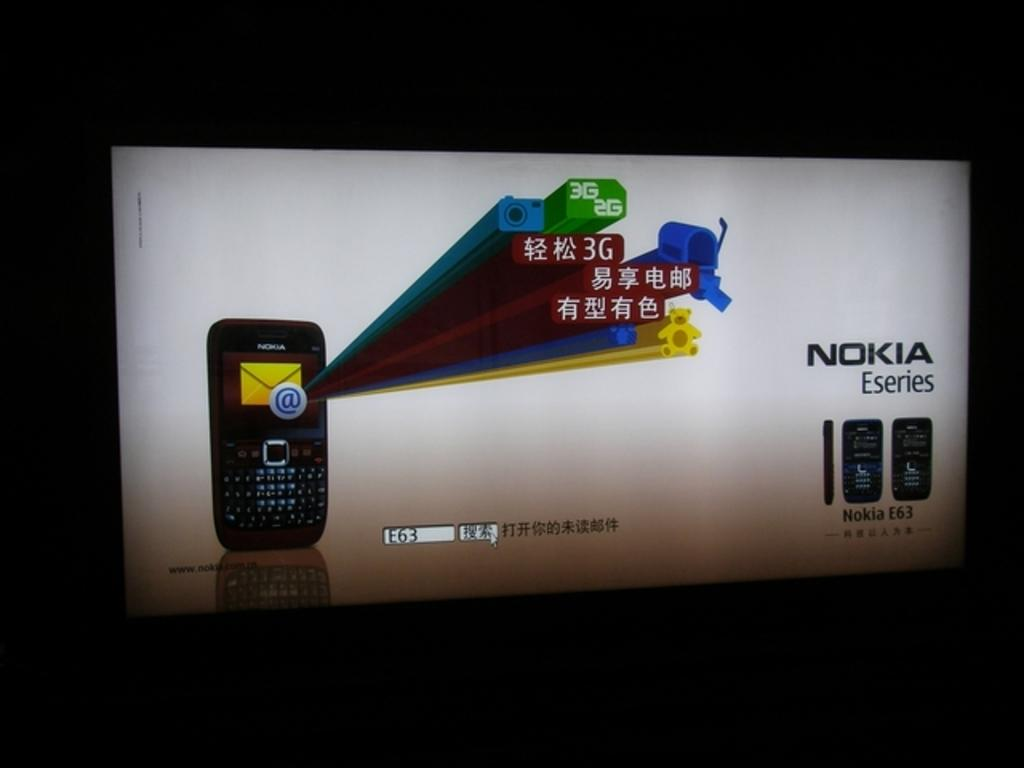<image>
Relay a brief, clear account of the picture shown. An ad for the Nokia E63 cell phone 